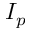Convert formula to latex. <formula><loc_0><loc_0><loc_500><loc_500>I _ { p }</formula> 